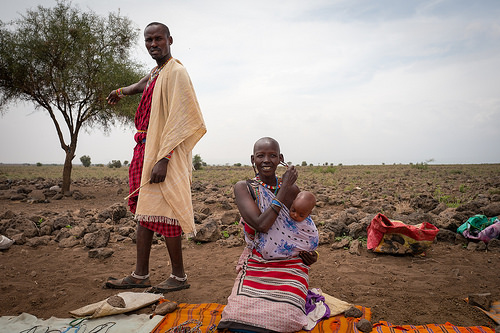<image>
Can you confirm if the bag is above the dirt? No. The bag is not positioned above the dirt. The vertical arrangement shows a different relationship. 